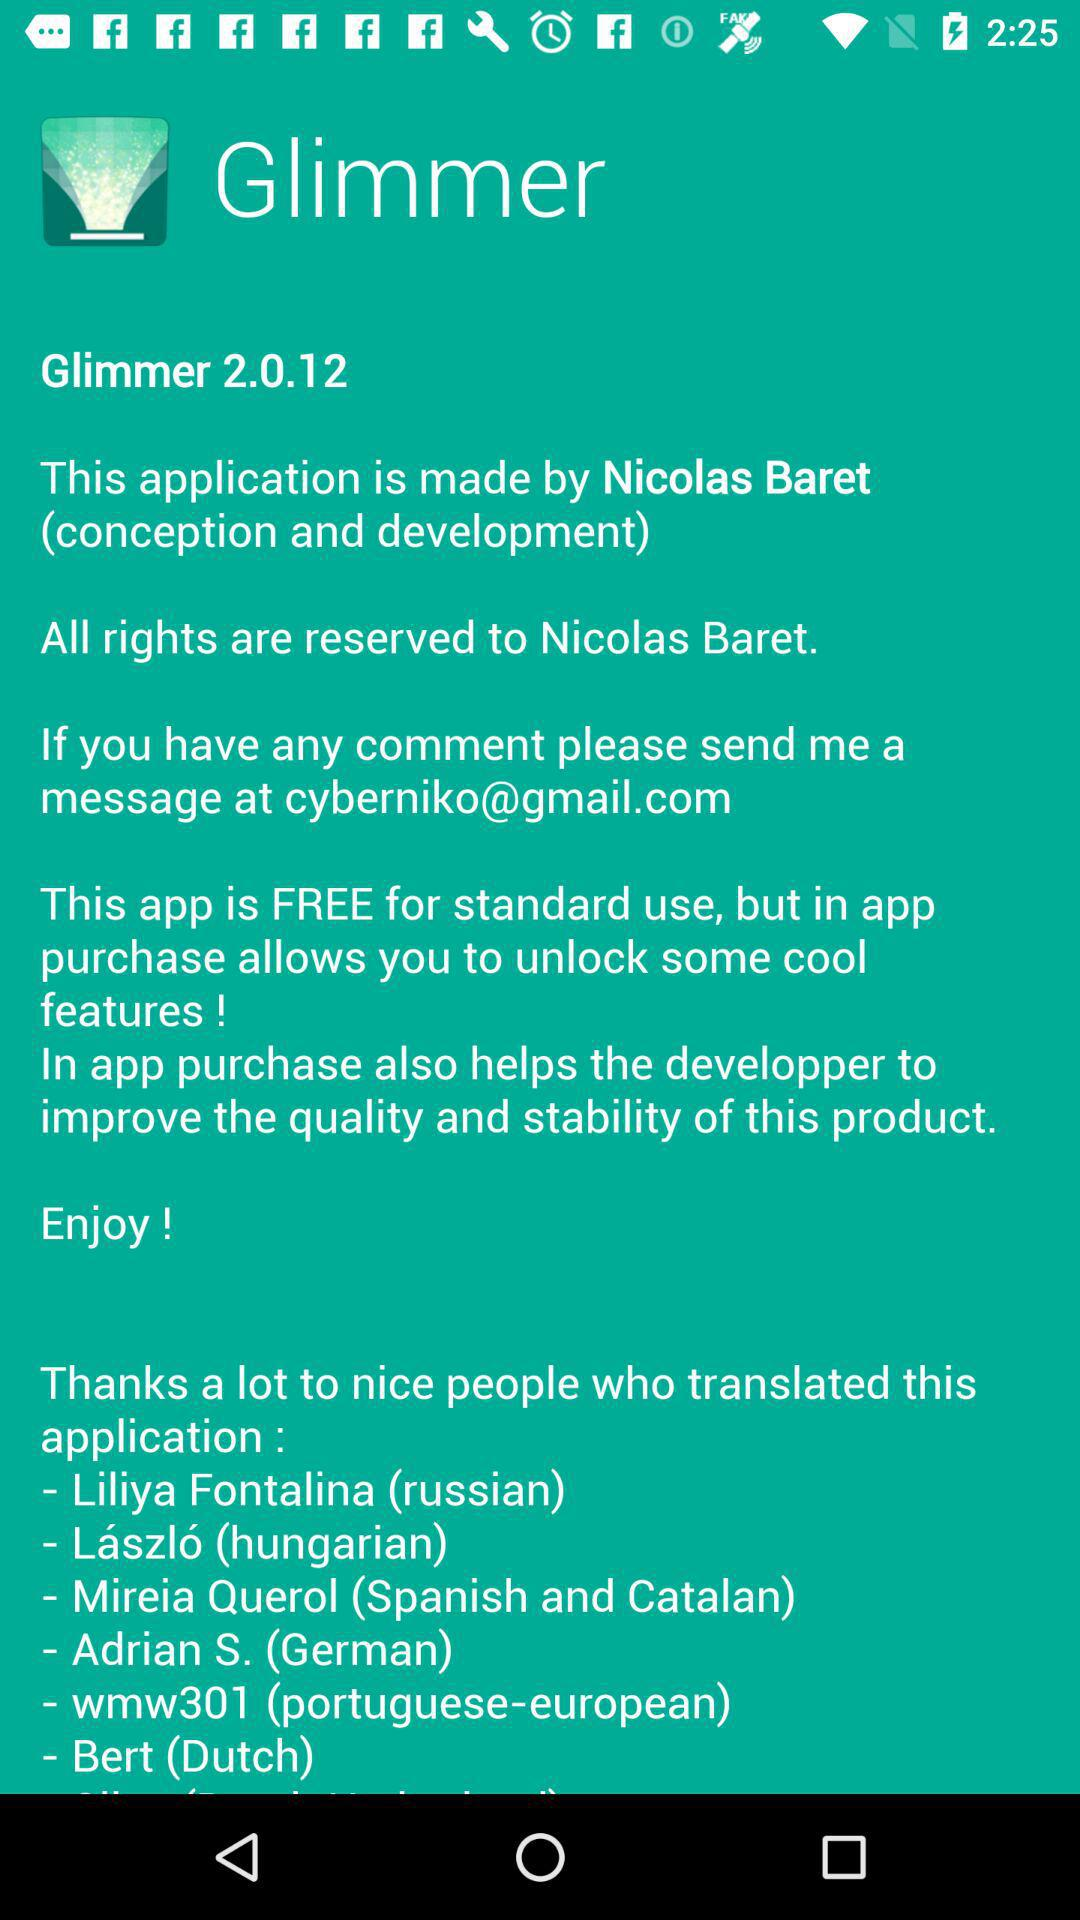Who is the Russian translator? The Russian translator is Liliya Fontalina. 